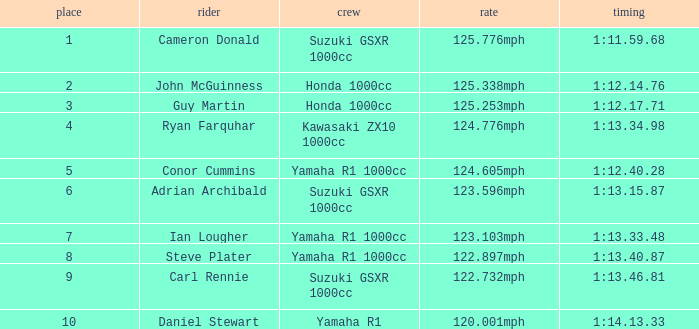What time did team kawasaki zx10 1000cc have? 1:13.34.98. 